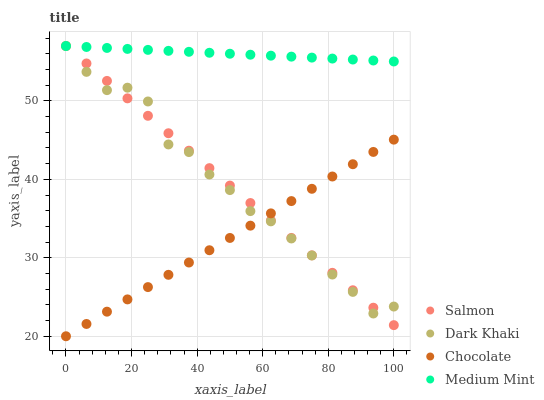Does Chocolate have the minimum area under the curve?
Answer yes or no. Yes. Does Medium Mint have the maximum area under the curve?
Answer yes or no. Yes. Does Salmon have the minimum area under the curve?
Answer yes or no. No. Does Salmon have the maximum area under the curve?
Answer yes or no. No. Is Chocolate the smoothest?
Answer yes or no. Yes. Is Dark Khaki the roughest?
Answer yes or no. Yes. Is Medium Mint the smoothest?
Answer yes or no. No. Is Medium Mint the roughest?
Answer yes or no. No. Does Chocolate have the lowest value?
Answer yes or no. Yes. Does Salmon have the lowest value?
Answer yes or no. No. Does Salmon have the highest value?
Answer yes or no. Yes. Does Chocolate have the highest value?
Answer yes or no. No. Is Chocolate less than Medium Mint?
Answer yes or no. Yes. Is Medium Mint greater than Chocolate?
Answer yes or no. Yes. Does Medium Mint intersect Salmon?
Answer yes or no. Yes. Is Medium Mint less than Salmon?
Answer yes or no. No. Is Medium Mint greater than Salmon?
Answer yes or no. No. Does Chocolate intersect Medium Mint?
Answer yes or no. No. 